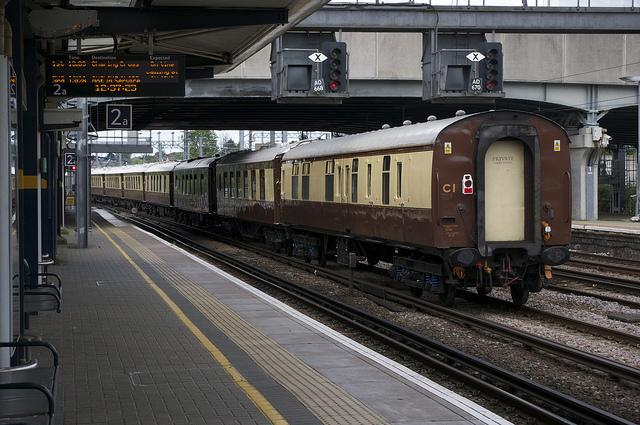What are the passengers told to wait behind? yellow line 